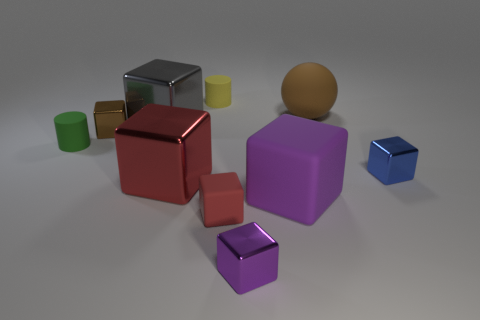How many matte things are red things or large spheres?
Keep it short and to the point. 2. There is a tiny block that is both to the left of the small blue shiny object and behind the small red cube; what material is it?
Your answer should be compact. Metal. There is a big rubber object that is behind the small cylinder left of the large gray metal thing; is there a small blue thing behind it?
Offer a terse response. No. There is a blue thing that is the same material as the tiny brown block; what shape is it?
Your answer should be compact. Cube. Is the number of rubber spheres to the right of the blue shiny cube less than the number of small objects in front of the big red metal cube?
Offer a very short reply. Yes. What number of small objects are purple metal objects or brown metal cubes?
Make the answer very short. 2. Is the shape of the small brown shiny object that is behind the green rubber cylinder the same as the purple thing that is behind the small red matte object?
Provide a succinct answer. Yes. What is the size of the shiny block on the right side of the brown object that is on the right side of the matte block on the right side of the red rubber cube?
Make the answer very short. Small. There is a brown metallic block to the left of the tiny blue metallic block; what is its size?
Your response must be concise. Small. What material is the red thing that is to the right of the small yellow rubber cylinder?
Provide a short and direct response. Rubber. 